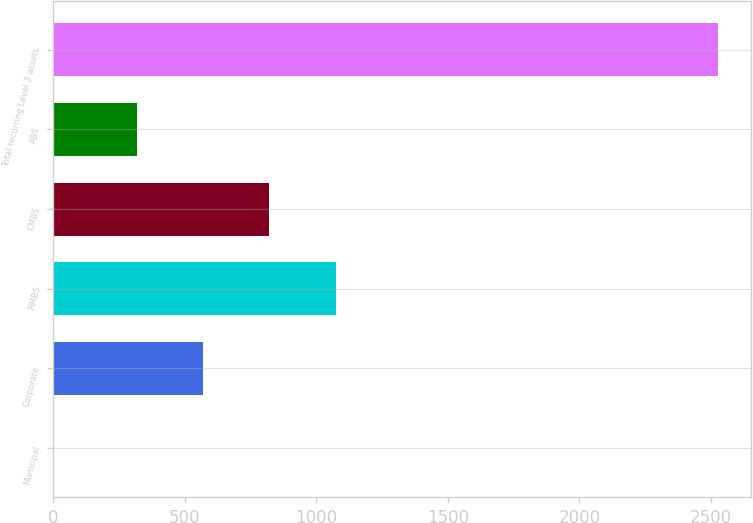Convert chart. <chart><loc_0><loc_0><loc_500><loc_500><bar_chart><fcel>Municipal<fcel>Corporate<fcel>RMBS<fcel>CMBS<fcel>ABS<fcel>Total recurring Level 3 assets<nl><fcel>3<fcel>568.2<fcel>1072.6<fcel>820.4<fcel>316<fcel>2525<nl></chart> 